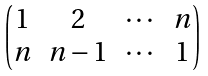<formula> <loc_0><loc_0><loc_500><loc_500>\begin{pmatrix} 1 & 2 & \cdots & n \\ n & n - 1 & \cdots & 1 \end{pmatrix}</formula> 